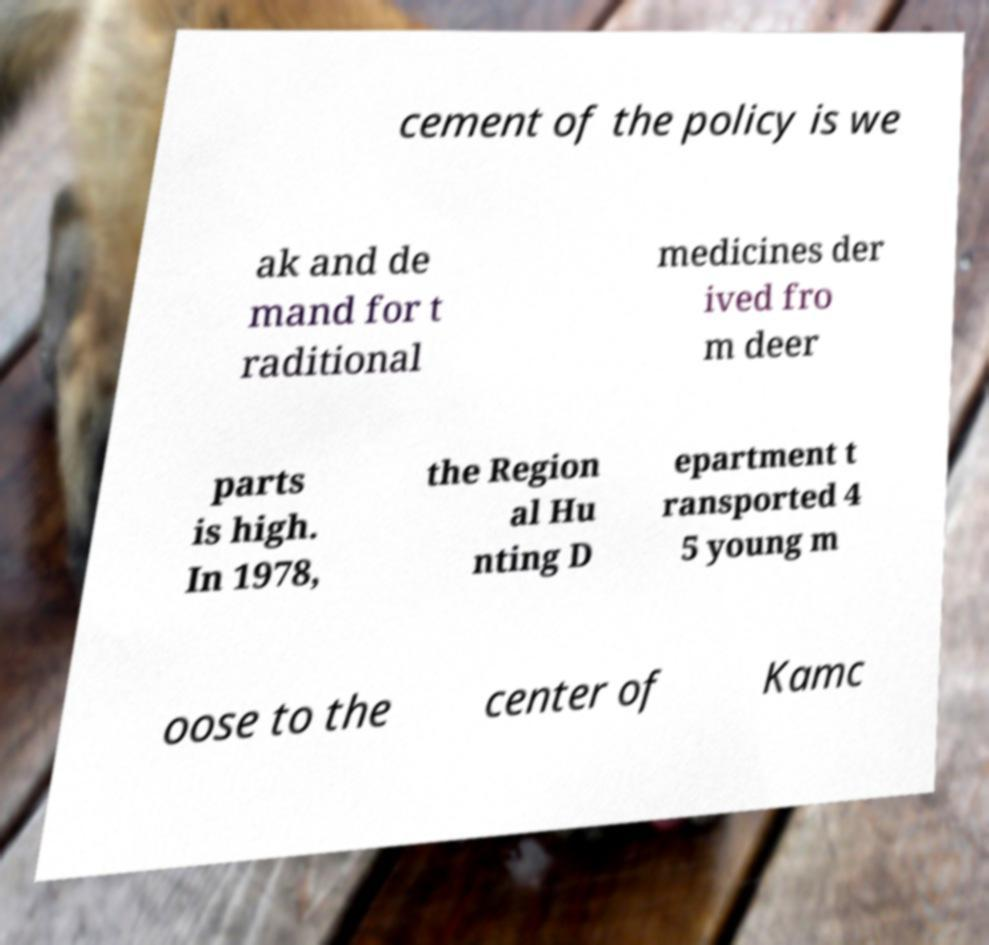What messages or text are displayed in this image? I need them in a readable, typed format. cement of the policy is we ak and de mand for t raditional medicines der ived fro m deer parts is high. In 1978, the Region al Hu nting D epartment t ransported 4 5 young m oose to the center of Kamc 